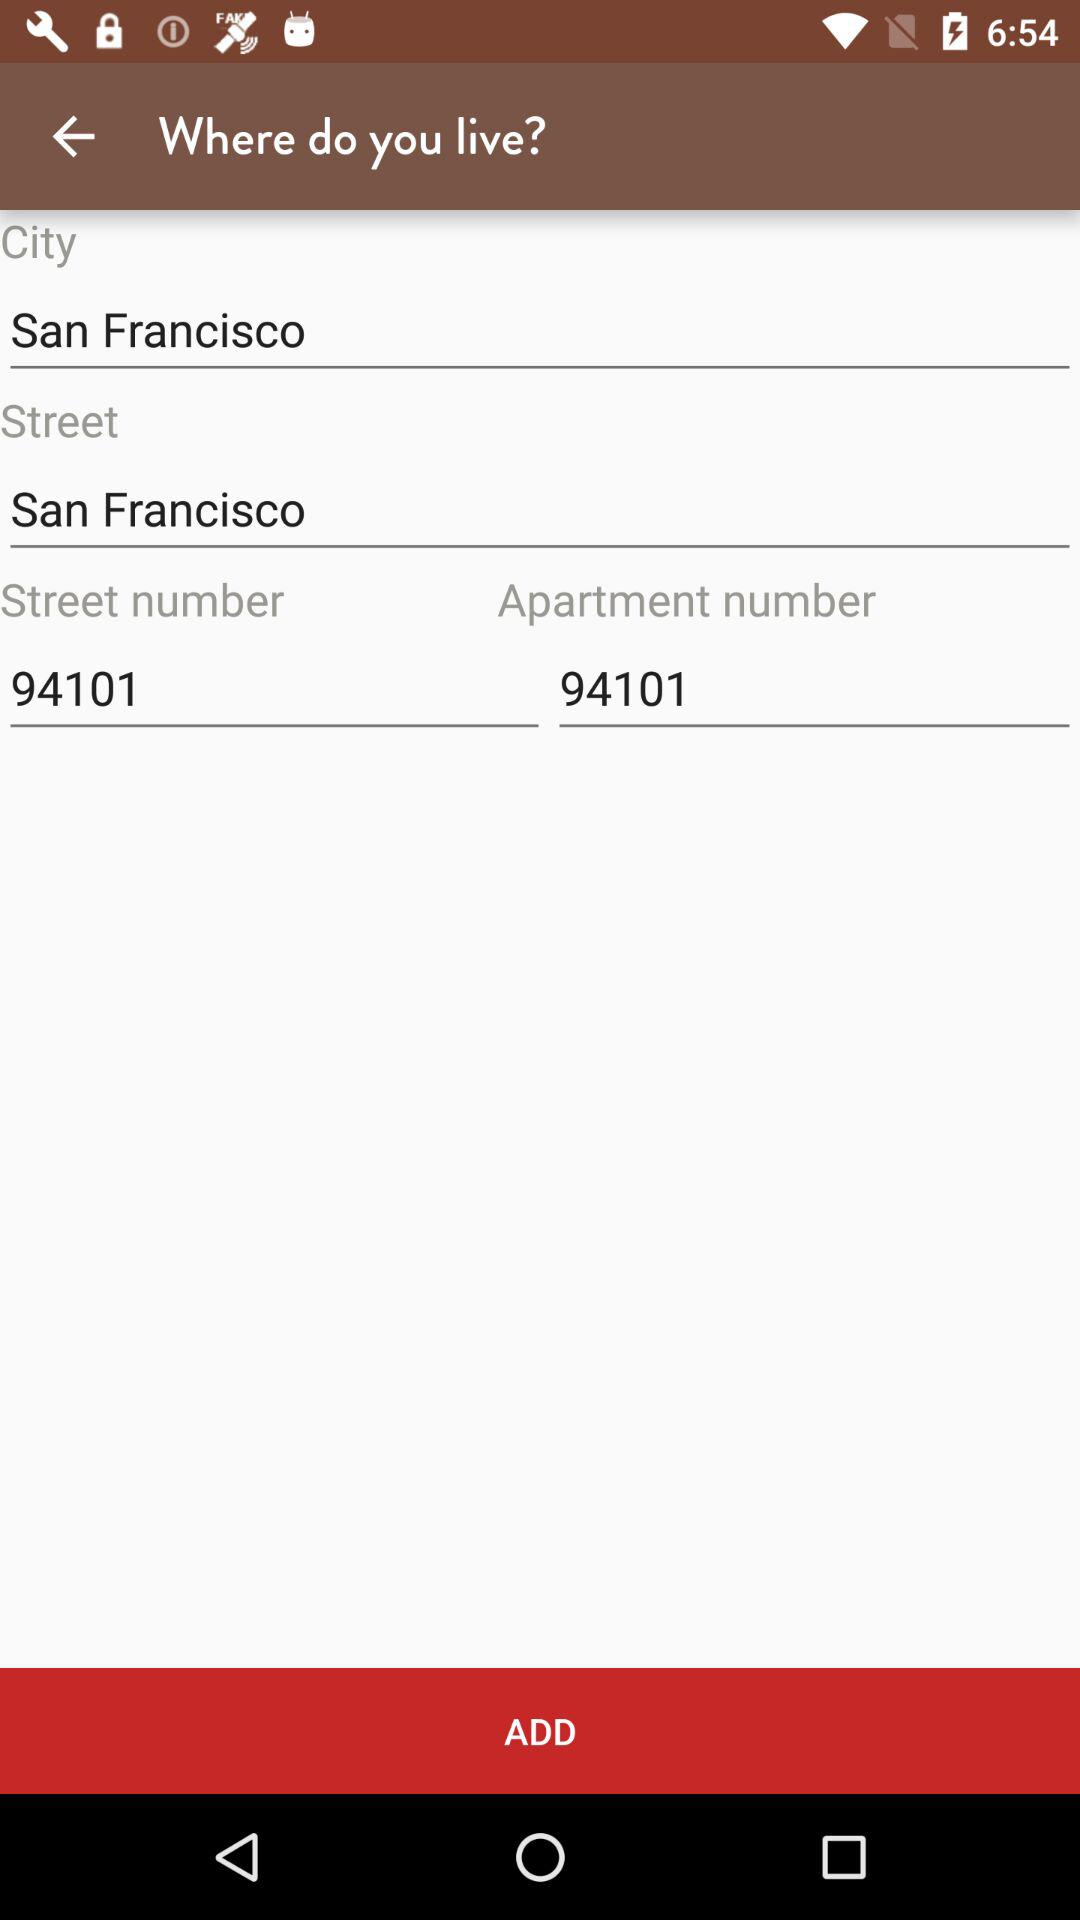What is the selected city? The selected city is "San Francisco". 